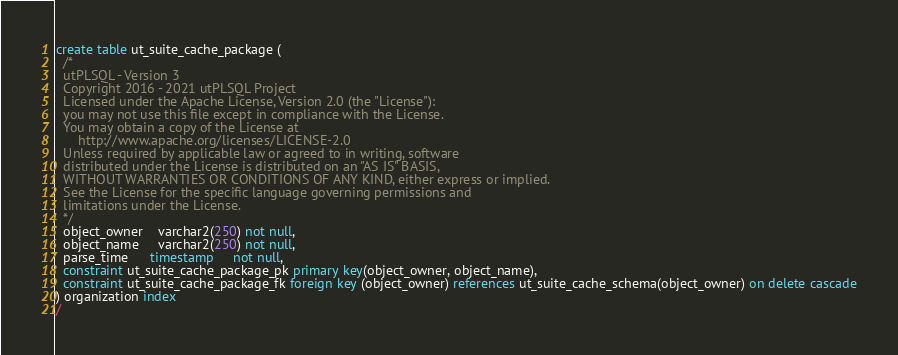<code> <loc_0><loc_0><loc_500><loc_500><_SQL_>create table ut_suite_cache_package (
  /*
  utPLSQL - Version 3
  Copyright 2016 - 2021 utPLSQL Project
  Licensed under the Apache License, Version 2.0 (the "License"):
  you may not use this file except in compliance with the License.
  You may obtain a copy of the License at
      http://www.apache.org/licenses/LICENSE-2.0
  Unless required by applicable law or agreed to in writing, software
  distributed under the License is distributed on an "AS IS" BASIS,
  WITHOUT WARRANTIES OR CONDITIONS OF ANY KIND, either express or implied.
  See the License for the specific language governing permissions and
  limitations under the License.
  */
  object_owner    varchar2(250) not null,
  object_name     varchar2(250) not null,
  parse_time      timestamp     not null,
  constraint ut_suite_cache_package_pk primary key(object_owner, object_name),
  constraint ut_suite_cache_package_fk foreign key (object_owner) references ut_suite_cache_schema(object_owner) on delete cascade
) organization index
/


</code> 